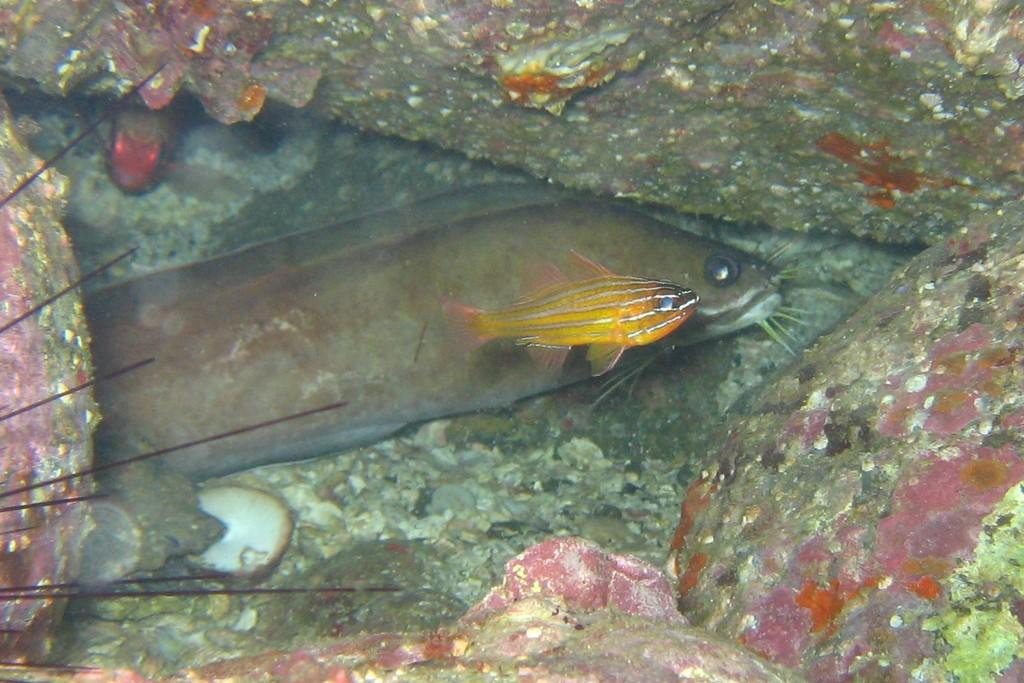How many fishes are in the image? There are two fishes in the image. Can you describe the size of the fishes? One fish is small, and the other fish is big. What type of soap is being used to clean the fishes in the image? There is no soap or cleaning activity involving the fishes in the image. 